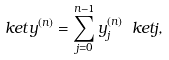<formula> <loc_0><loc_0><loc_500><loc_500>\ k e t { y ^ { ( n ) } } = \sum _ { j = 0 } ^ { n - 1 } y _ { j } ^ { ( n ) } \ k e t { j } ,</formula> 